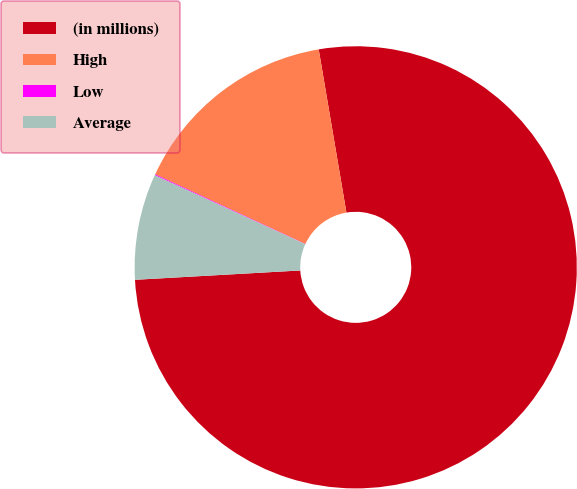Convert chart. <chart><loc_0><loc_0><loc_500><loc_500><pie_chart><fcel>(in millions)<fcel>High<fcel>Low<fcel>Average<nl><fcel>76.78%<fcel>15.41%<fcel>0.07%<fcel>7.74%<nl></chart> 